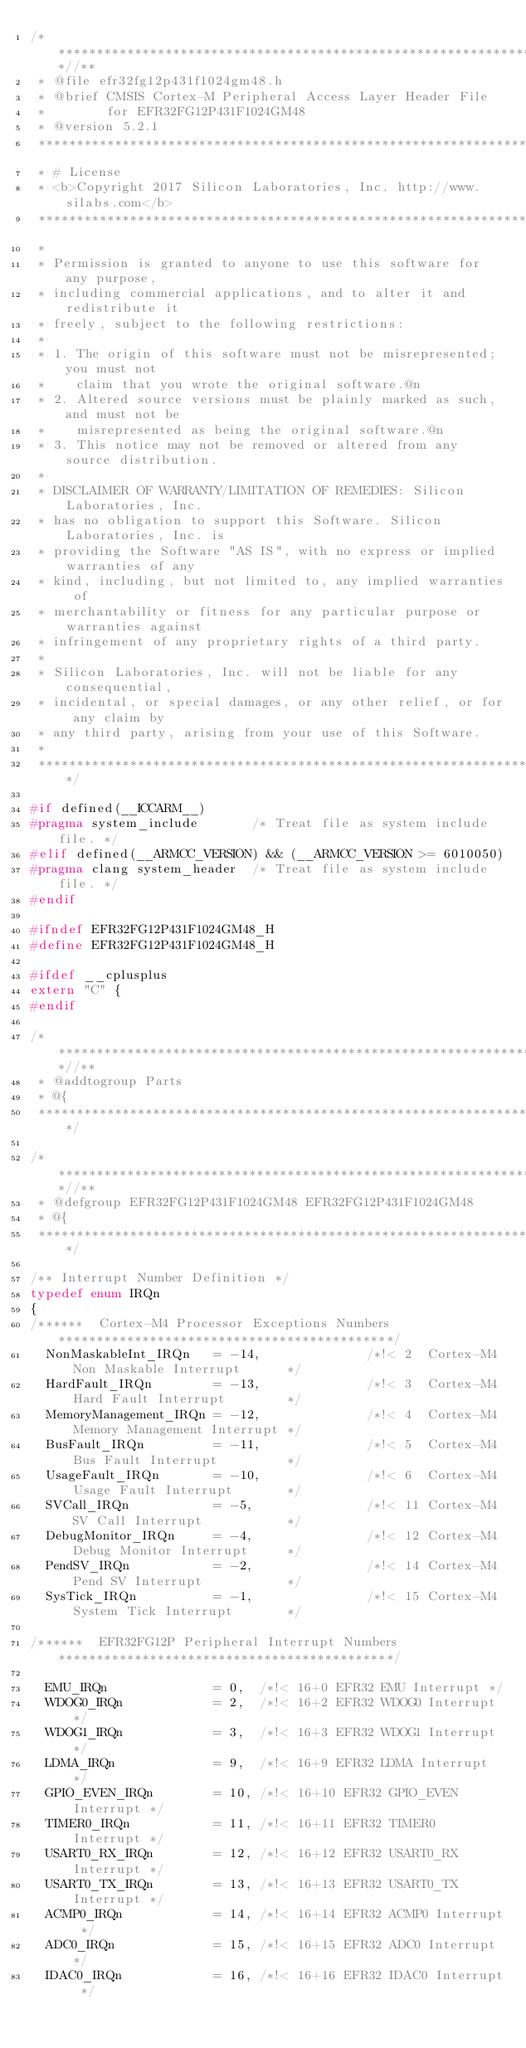<code> <loc_0><loc_0><loc_500><loc_500><_C_>/**************************************************************************//**
 * @file efr32fg12p431f1024gm48.h
 * @brief CMSIS Cortex-M Peripheral Access Layer Header File
 *        for EFR32FG12P431F1024GM48
 * @version 5.2.1
 ******************************************************************************
 * # License
 * <b>Copyright 2017 Silicon Laboratories, Inc. http://www.silabs.com</b>
 ******************************************************************************
 *
 * Permission is granted to anyone to use this software for any purpose,
 * including commercial applications, and to alter it and redistribute it
 * freely, subject to the following restrictions:
 *
 * 1. The origin of this software must not be misrepresented; you must not
 *    claim that you wrote the original software.@n
 * 2. Altered source versions must be plainly marked as such, and must not be
 *    misrepresented as being the original software.@n
 * 3. This notice may not be removed or altered from any source distribution.
 *
 * DISCLAIMER OF WARRANTY/LIMITATION OF REMEDIES: Silicon Laboratories, Inc.
 * has no obligation to support this Software. Silicon Laboratories, Inc. is
 * providing the Software "AS IS", with no express or implied warranties of any
 * kind, including, but not limited to, any implied warranties of
 * merchantability or fitness for any particular purpose or warranties against
 * infringement of any proprietary rights of a third party.
 *
 * Silicon Laboratories, Inc. will not be liable for any consequential,
 * incidental, or special damages, or any other relief, or for any claim by
 * any third party, arising from your use of this Software.
 *
 *****************************************************************************/

#if defined(__ICCARM__)
#pragma system_include       /* Treat file as system include file. */
#elif defined(__ARMCC_VERSION) && (__ARMCC_VERSION >= 6010050)
#pragma clang system_header  /* Treat file as system include file. */
#endif

#ifndef EFR32FG12P431F1024GM48_H
#define EFR32FG12P431F1024GM48_H

#ifdef __cplusplus
extern "C" {
#endif

/**************************************************************************//**
 * @addtogroup Parts
 * @{
 *****************************************************************************/

/**************************************************************************//**
 * @defgroup EFR32FG12P431F1024GM48 EFR32FG12P431F1024GM48
 * @{
 *****************************************************************************/

/** Interrupt Number Definition */
typedef enum IRQn
{
/******  Cortex-M4 Processor Exceptions Numbers ********************************************/
  NonMaskableInt_IRQn   = -14,              /*!< 2  Cortex-M4 Non Maskable Interrupt      */
  HardFault_IRQn        = -13,              /*!< 3  Cortex-M4 Hard Fault Interrupt        */
  MemoryManagement_IRQn = -12,              /*!< 4  Cortex-M4 Memory Management Interrupt */
  BusFault_IRQn         = -11,              /*!< 5  Cortex-M4 Bus Fault Interrupt         */
  UsageFault_IRQn       = -10,              /*!< 6  Cortex-M4 Usage Fault Interrupt       */
  SVCall_IRQn           = -5,               /*!< 11 Cortex-M4 SV Call Interrupt           */
  DebugMonitor_IRQn     = -4,               /*!< 12 Cortex-M4 Debug Monitor Interrupt     */
  PendSV_IRQn           = -2,               /*!< 14 Cortex-M4 Pend SV Interrupt           */
  SysTick_IRQn          = -1,               /*!< 15 Cortex-M4 System Tick Interrupt       */

/******  EFR32FG12P Peripheral Interrupt Numbers ********************************************/

  EMU_IRQn              = 0,  /*!< 16+0 EFR32 EMU Interrupt */
  WDOG0_IRQn            = 2,  /*!< 16+2 EFR32 WDOG0 Interrupt */
  WDOG1_IRQn            = 3,  /*!< 16+3 EFR32 WDOG1 Interrupt */
  LDMA_IRQn             = 9,  /*!< 16+9 EFR32 LDMA Interrupt */
  GPIO_EVEN_IRQn        = 10, /*!< 16+10 EFR32 GPIO_EVEN Interrupt */
  TIMER0_IRQn           = 11, /*!< 16+11 EFR32 TIMER0 Interrupt */
  USART0_RX_IRQn        = 12, /*!< 16+12 EFR32 USART0_RX Interrupt */
  USART0_TX_IRQn        = 13, /*!< 16+13 EFR32 USART0_TX Interrupt */
  ACMP0_IRQn            = 14, /*!< 16+14 EFR32 ACMP0 Interrupt */
  ADC0_IRQn             = 15, /*!< 16+15 EFR32 ADC0 Interrupt */
  IDAC0_IRQn            = 16, /*!< 16+16 EFR32 IDAC0 Interrupt */</code> 